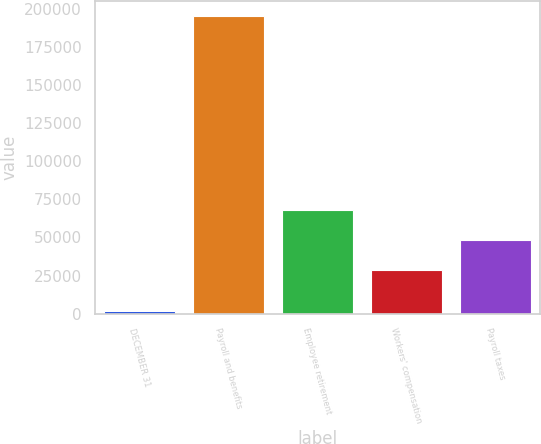<chart> <loc_0><loc_0><loc_500><loc_500><bar_chart><fcel>DECEMBER 31<fcel>Payroll and benefits<fcel>Employee retirement<fcel>Workers' compensation<fcel>Payroll taxes<nl><fcel>2007<fcel>195383<fcel>67671.2<fcel>28996<fcel>48333.6<nl></chart> 